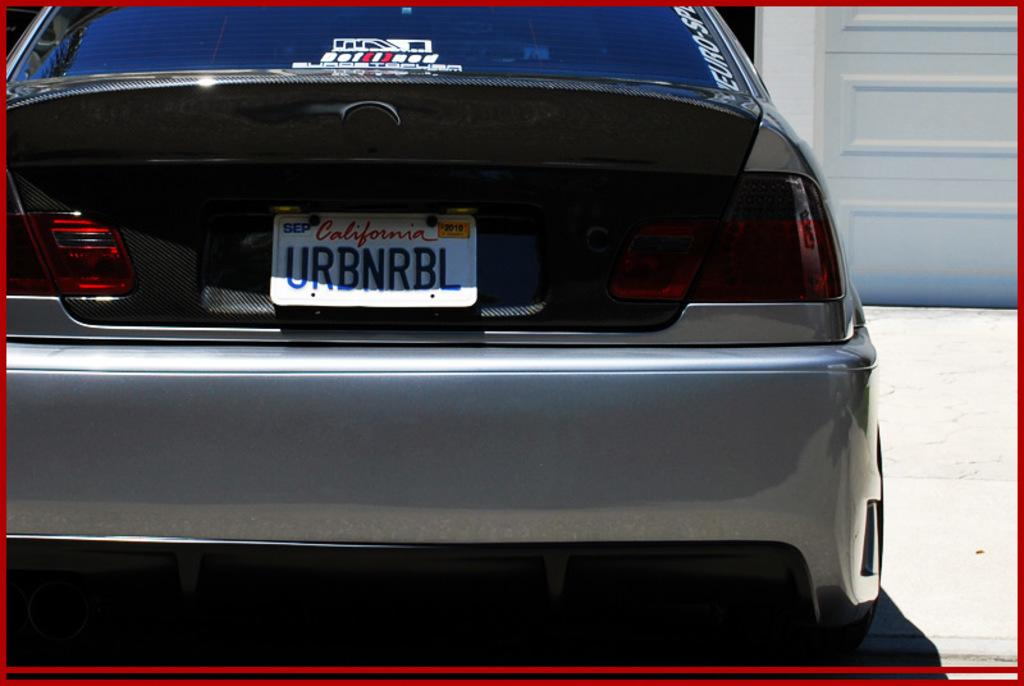<image>
Relay a brief, clear account of the picture shown. California license plate which says URBNRBL on it. 